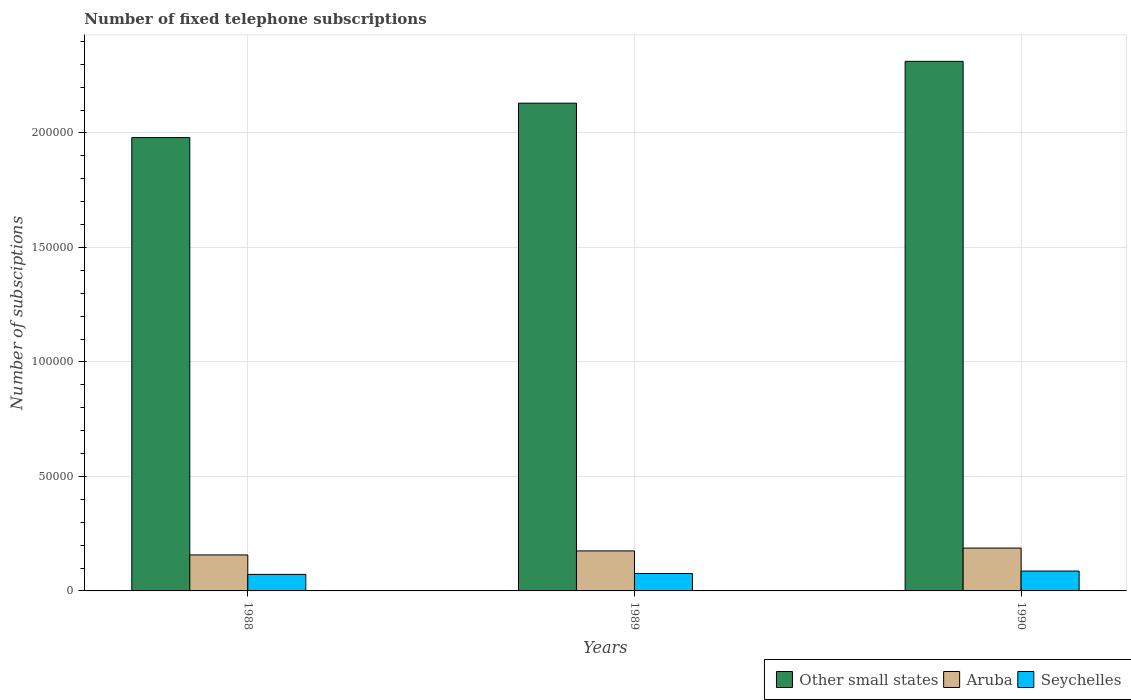How many different coloured bars are there?
Make the answer very short. 3. How many groups of bars are there?
Provide a short and direct response. 3. Are the number of bars on each tick of the X-axis equal?
Keep it short and to the point. Yes. How many bars are there on the 3rd tick from the left?
Offer a terse response. 3. In how many cases, is the number of bars for a given year not equal to the number of legend labels?
Give a very brief answer. 0. What is the number of fixed telephone subscriptions in Seychelles in 1989?
Provide a short and direct response. 7610.5. Across all years, what is the maximum number of fixed telephone subscriptions in Aruba?
Offer a very short reply. 1.87e+04. Across all years, what is the minimum number of fixed telephone subscriptions in Seychelles?
Your response must be concise. 7221. In which year was the number of fixed telephone subscriptions in Seychelles maximum?
Your answer should be very brief. 1990. What is the total number of fixed telephone subscriptions in Other small states in the graph?
Your response must be concise. 6.42e+05. What is the difference between the number of fixed telephone subscriptions in Aruba in 1988 and that in 1990?
Provide a short and direct response. -2994. What is the difference between the number of fixed telephone subscriptions in Aruba in 1988 and the number of fixed telephone subscriptions in Seychelles in 1990?
Your answer should be very brief. 7039. What is the average number of fixed telephone subscriptions in Aruba per year?
Keep it short and to the point. 1.73e+04. In the year 1989, what is the difference between the number of fixed telephone subscriptions in Other small states and number of fixed telephone subscriptions in Aruba?
Give a very brief answer. 1.96e+05. In how many years, is the number of fixed telephone subscriptions in Other small states greater than 70000?
Offer a very short reply. 3. What is the ratio of the number of fixed telephone subscriptions in Seychelles in 1988 to that in 1989?
Ensure brevity in your answer.  0.95. Is the number of fixed telephone subscriptions in Other small states in 1988 less than that in 1989?
Your answer should be very brief. Yes. What is the difference between the highest and the second highest number of fixed telephone subscriptions in Other small states?
Offer a very short reply. 1.83e+04. What is the difference between the highest and the lowest number of fixed telephone subscriptions in Seychelles?
Provide a short and direct response. 1458. In how many years, is the number of fixed telephone subscriptions in Other small states greater than the average number of fixed telephone subscriptions in Other small states taken over all years?
Provide a succinct answer. 1. Is the sum of the number of fixed telephone subscriptions in Other small states in 1988 and 1989 greater than the maximum number of fixed telephone subscriptions in Seychelles across all years?
Keep it short and to the point. Yes. What does the 1st bar from the left in 1990 represents?
Your response must be concise. Other small states. What does the 1st bar from the right in 1988 represents?
Make the answer very short. Seychelles. How many bars are there?
Keep it short and to the point. 9. How many years are there in the graph?
Offer a very short reply. 3. What is the difference between two consecutive major ticks on the Y-axis?
Your response must be concise. 5.00e+04. Are the values on the major ticks of Y-axis written in scientific E-notation?
Your answer should be very brief. No. Does the graph contain grids?
Offer a very short reply. Yes. How are the legend labels stacked?
Keep it short and to the point. Horizontal. What is the title of the graph?
Ensure brevity in your answer.  Number of fixed telephone subscriptions. What is the label or title of the X-axis?
Give a very brief answer. Years. What is the label or title of the Y-axis?
Make the answer very short. Number of subsciptions. What is the Number of subsciptions in Other small states in 1988?
Make the answer very short. 1.98e+05. What is the Number of subsciptions of Aruba in 1988?
Ensure brevity in your answer.  1.57e+04. What is the Number of subsciptions in Seychelles in 1988?
Keep it short and to the point. 7221. What is the Number of subsciptions of Other small states in 1989?
Make the answer very short. 2.13e+05. What is the Number of subsciptions in Aruba in 1989?
Make the answer very short. 1.75e+04. What is the Number of subsciptions in Seychelles in 1989?
Give a very brief answer. 7610.5. What is the Number of subsciptions in Other small states in 1990?
Provide a succinct answer. 2.31e+05. What is the Number of subsciptions of Aruba in 1990?
Your answer should be compact. 1.87e+04. What is the Number of subsciptions in Seychelles in 1990?
Give a very brief answer. 8679. Across all years, what is the maximum Number of subsciptions of Other small states?
Provide a succinct answer. 2.31e+05. Across all years, what is the maximum Number of subsciptions of Aruba?
Make the answer very short. 1.87e+04. Across all years, what is the maximum Number of subsciptions of Seychelles?
Your response must be concise. 8679. Across all years, what is the minimum Number of subsciptions of Other small states?
Keep it short and to the point. 1.98e+05. Across all years, what is the minimum Number of subsciptions of Aruba?
Provide a short and direct response. 1.57e+04. Across all years, what is the minimum Number of subsciptions in Seychelles?
Provide a succinct answer. 7221. What is the total Number of subsciptions in Other small states in the graph?
Offer a very short reply. 6.42e+05. What is the total Number of subsciptions in Aruba in the graph?
Your answer should be very brief. 5.19e+04. What is the total Number of subsciptions in Seychelles in the graph?
Keep it short and to the point. 2.35e+04. What is the difference between the Number of subsciptions of Other small states in 1988 and that in 1989?
Your response must be concise. -1.50e+04. What is the difference between the Number of subsciptions in Aruba in 1988 and that in 1989?
Provide a short and direct response. -1751. What is the difference between the Number of subsciptions of Seychelles in 1988 and that in 1989?
Make the answer very short. -389.5. What is the difference between the Number of subsciptions of Other small states in 1988 and that in 1990?
Give a very brief answer. -3.33e+04. What is the difference between the Number of subsciptions of Aruba in 1988 and that in 1990?
Keep it short and to the point. -2994. What is the difference between the Number of subsciptions of Seychelles in 1988 and that in 1990?
Your answer should be very brief. -1458. What is the difference between the Number of subsciptions in Other small states in 1989 and that in 1990?
Your answer should be very brief. -1.83e+04. What is the difference between the Number of subsciptions in Aruba in 1989 and that in 1990?
Give a very brief answer. -1243. What is the difference between the Number of subsciptions in Seychelles in 1989 and that in 1990?
Offer a terse response. -1068.5. What is the difference between the Number of subsciptions of Other small states in 1988 and the Number of subsciptions of Aruba in 1989?
Your answer should be very brief. 1.81e+05. What is the difference between the Number of subsciptions of Other small states in 1988 and the Number of subsciptions of Seychelles in 1989?
Keep it short and to the point. 1.90e+05. What is the difference between the Number of subsciptions in Aruba in 1988 and the Number of subsciptions in Seychelles in 1989?
Offer a very short reply. 8107.5. What is the difference between the Number of subsciptions of Other small states in 1988 and the Number of subsciptions of Aruba in 1990?
Your answer should be very brief. 1.79e+05. What is the difference between the Number of subsciptions in Other small states in 1988 and the Number of subsciptions in Seychelles in 1990?
Keep it short and to the point. 1.89e+05. What is the difference between the Number of subsciptions of Aruba in 1988 and the Number of subsciptions of Seychelles in 1990?
Provide a succinct answer. 7039. What is the difference between the Number of subsciptions of Other small states in 1989 and the Number of subsciptions of Aruba in 1990?
Give a very brief answer. 1.94e+05. What is the difference between the Number of subsciptions of Other small states in 1989 and the Number of subsciptions of Seychelles in 1990?
Ensure brevity in your answer.  2.04e+05. What is the difference between the Number of subsciptions in Aruba in 1989 and the Number of subsciptions in Seychelles in 1990?
Provide a short and direct response. 8790. What is the average Number of subsciptions in Other small states per year?
Your answer should be very brief. 2.14e+05. What is the average Number of subsciptions of Aruba per year?
Ensure brevity in your answer.  1.73e+04. What is the average Number of subsciptions in Seychelles per year?
Provide a short and direct response. 7836.83. In the year 1988, what is the difference between the Number of subsciptions in Other small states and Number of subsciptions in Aruba?
Your response must be concise. 1.82e+05. In the year 1988, what is the difference between the Number of subsciptions of Other small states and Number of subsciptions of Seychelles?
Your answer should be very brief. 1.91e+05. In the year 1988, what is the difference between the Number of subsciptions of Aruba and Number of subsciptions of Seychelles?
Keep it short and to the point. 8497. In the year 1989, what is the difference between the Number of subsciptions of Other small states and Number of subsciptions of Aruba?
Your response must be concise. 1.96e+05. In the year 1989, what is the difference between the Number of subsciptions in Other small states and Number of subsciptions in Seychelles?
Your answer should be compact. 2.05e+05. In the year 1989, what is the difference between the Number of subsciptions of Aruba and Number of subsciptions of Seychelles?
Provide a short and direct response. 9858.5. In the year 1990, what is the difference between the Number of subsciptions of Other small states and Number of subsciptions of Aruba?
Provide a succinct answer. 2.13e+05. In the year 1990, what is the difference between the Number of subsciptions of Other small states and Number of subsciptions of Seychelles?
Give a very brief answer. 2.23e+05. In the year 1990, what is the difference between the Number of subsciptions in Aruba and Number of subsciptions in Seychelles?
Make the answer very short. 1.00e+04. What is the ratio of the Number of subsciptions in Other small states in 1988 to that in 1989?
Keep it short and to the point. 0.93. What is the ratio of the Number of subsciptions in Aruba in 1988 to that in 1989?
Give a very brief answer. 0.9. What is the ratio of the Number of subsciptions in Seychelles in 1988 to that in 1989?
Offer a terse response. 0.95. What is the ratio of the Number of subsciptions of Other small states in 1988 to that in 1990?
Keep it short and to the point. 0.86. What is the ratio of the Number of subsciptions of Aruba in 1988 to that in 1990?
Provide a short and direct response. 0.84. What is the ratio of the Number of subsciptions in Seychelles in 1988 to that in 1990?
Your answer should be compact. 0.83. What is the ratio of the Number of subsciptions in Other small states in 1989 to that in 1990?
Keep it short and to the point. 0.92. What is the ratio of the Number of subsciptions of Aruba in 1989 to that in 1990?
Provide a short and direct response. 0.93. What is the ratio of the Number of subsciptions of Seychelles in 1989 to that in 1990?
Offer a terse response. 0.88. What is the difference between the highest and the second highest Number of subsciptions of Other small states?
Your answer should be very brief. 1.83e+04. What is the difference between the highest and the second highest Number of subsciptions in Aruba?
Your answer should be very brief. 1243. What is the difference between the highest and the second highest Number of subsciptions in Seychelles?
Give a very brief answer. 1068.5. What is the difference between the highest and the lowest Number of subsciptions in Other small states?
Provide a short and direct response. 3.33e+04. What is the difference between the highest and the lowest Number of subsciptions in Aruba?
Offer a terse response. 2994. What is the difference between the highest and the lowest Number of subsciptions in Seychelles?
Keep it short and to the point. 1458. 